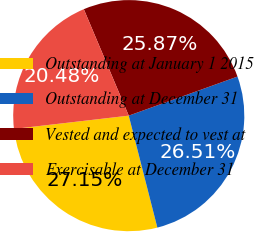<chart> <loc_0><loc_0><loc_500><loc_500><pie_chart><fcel>Outstanding at January 1 2015<fcel>Outstanding at December 31<fcel>Vested and expected to vest at<fcel>Exercisable at December 31<nl><fcel>27.15%<fcel>26.51%<fcel>25.87%<fcel>20.48%<nl></chart> 